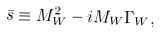Convert formula to latex. <formula><loc_0><loc_0><loc_500><loc_500>\bar { s } \equiv M _ { W } ^ { 2 } - i M _ { W } \Gamma _ { W } ,</formula> 